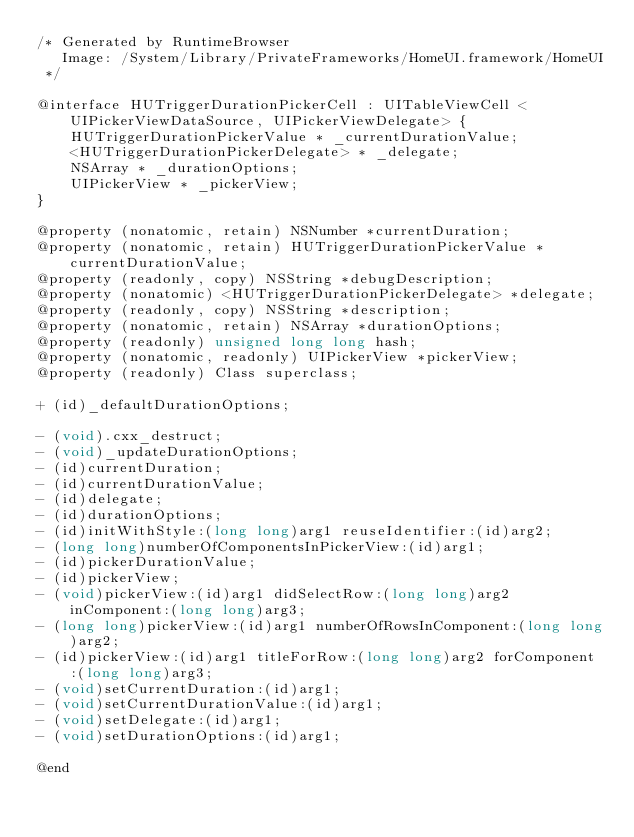Convert code to text. <code><loc_0><loc_0><loc_500><loc_500><_C_>/* Generated by RuntimeBrowser
   Image: /System/Library/PrivateFrameworks/HomeUI.framework/HomeUI
 */

@interface HUTriggerDurationPickerCell : UITableViewCell <UIPickerViewDataSource, UIPickerViewDelegate> {
    HUTriggerDurationPickerValue * _currentDurationValue;
    <HUTriggerDurationPickerDelegate> * _delegate;
    NSArray * _durationOptions;
    UIPickerView * _pickerView;
}

@property (nonatomic, retain) NSNumber *currentDuration;
@property (nonatomic, retain) HUTriggerDurationPickerValue *currentDurationValue;
@property (readonly, copy) NSString *debugDescription;
@property (nonatomic) <HUTriggerDurationPickerDelegate> *delegate;
@property (readonly, copy) NSString *description;
@property (nonatomic, retain) NSArray *durationOptions;
@property (readonly) unsigned long long hash;
@property (nonatomic, readonly) UIPickerView *pickerView;
@property (readonly) Class superclass;

+ (id)_defaultDurationOptions;

- (void).cxx_destruct;
- (void)_updateDurationOptions;
- (id)currentDuration;
- (id)currentDurationValue;
- (id)delegate;
- (id)durationOptions;
- (id)initWithStyle:(long long)arg1 reuseIdentifier:(id)arg2;
- (long long)numberOfComponentsInPickerView:(id)arg1;
- (id)pickerDurationValue;
- (id)pickerView;
- (void)pickerView:(id)arg1 didSelectRow:(long long)arg2 inComponent:(long long)arg3;
- (long long)pickerView:(id)arg1 numberOfRowsInComponent:(long long)arg2;
- (id)pickerView:(id)arg1 titleForRow:(long long)arg2 forComponent:(long long)arg3;
- (void)setCurrentDuration:(id)arg1;
- (void)setCurrentDurationValue:(id)arg1;
- (void)setDelegate:(id)arg1;
- (void)setDurationOptions:(id)arg1;

@end
</code> 